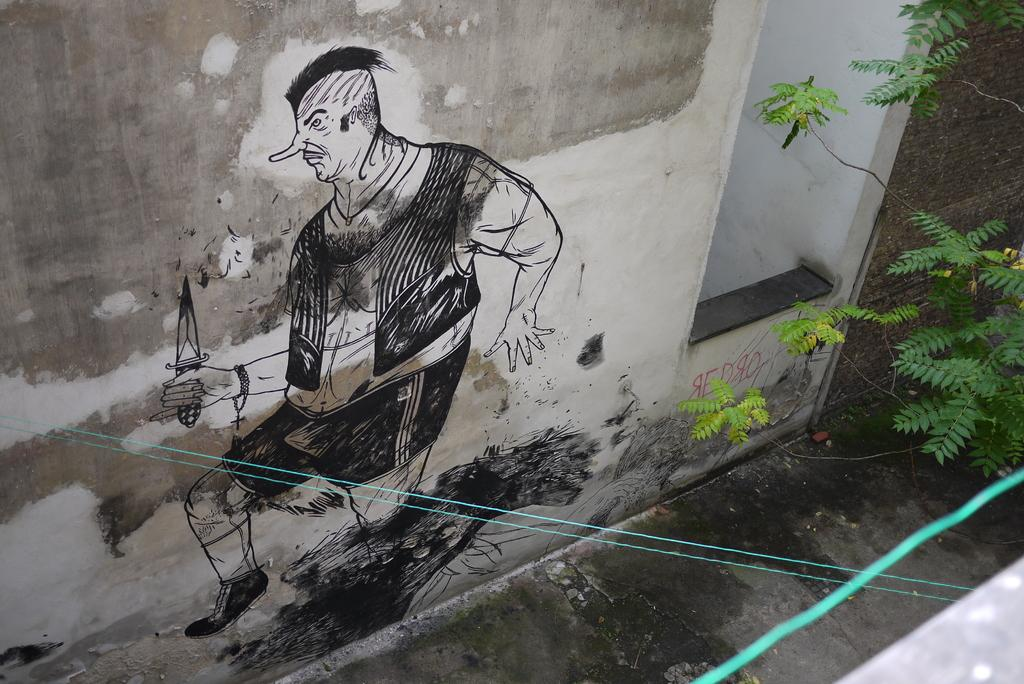What is present on the wall in the image? There is a painting of a person holding a knife on the wall. What can be seen on the right side of the image? There are leaves visible on the right side of the image. What type of skin condition can be seen on the person in the painting? There is no skin condition visible on the person in the painting, as it is a two-dimensional representation. 